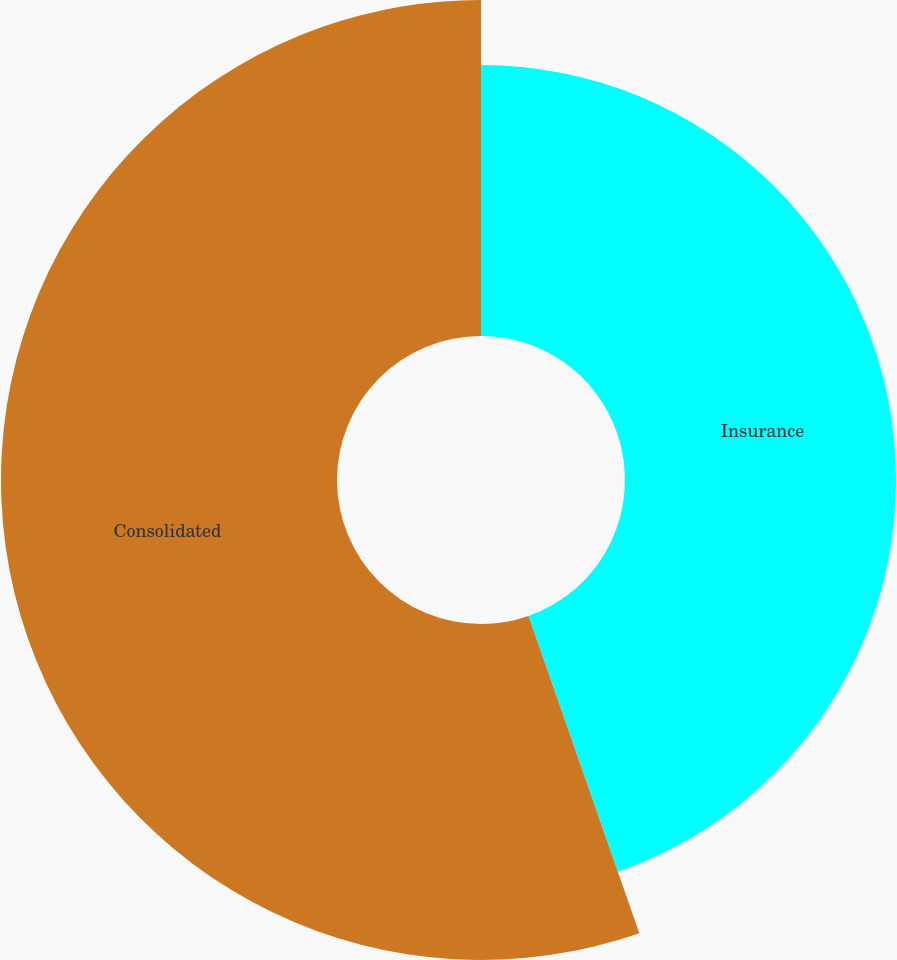<chart> <loc_0><loc_0><loc_500><loc_500><pie_chart><fcel>Insurance<fcel>Consolidated<nl><fcel>44.65%<fcel>55.35%<nl></chart> 